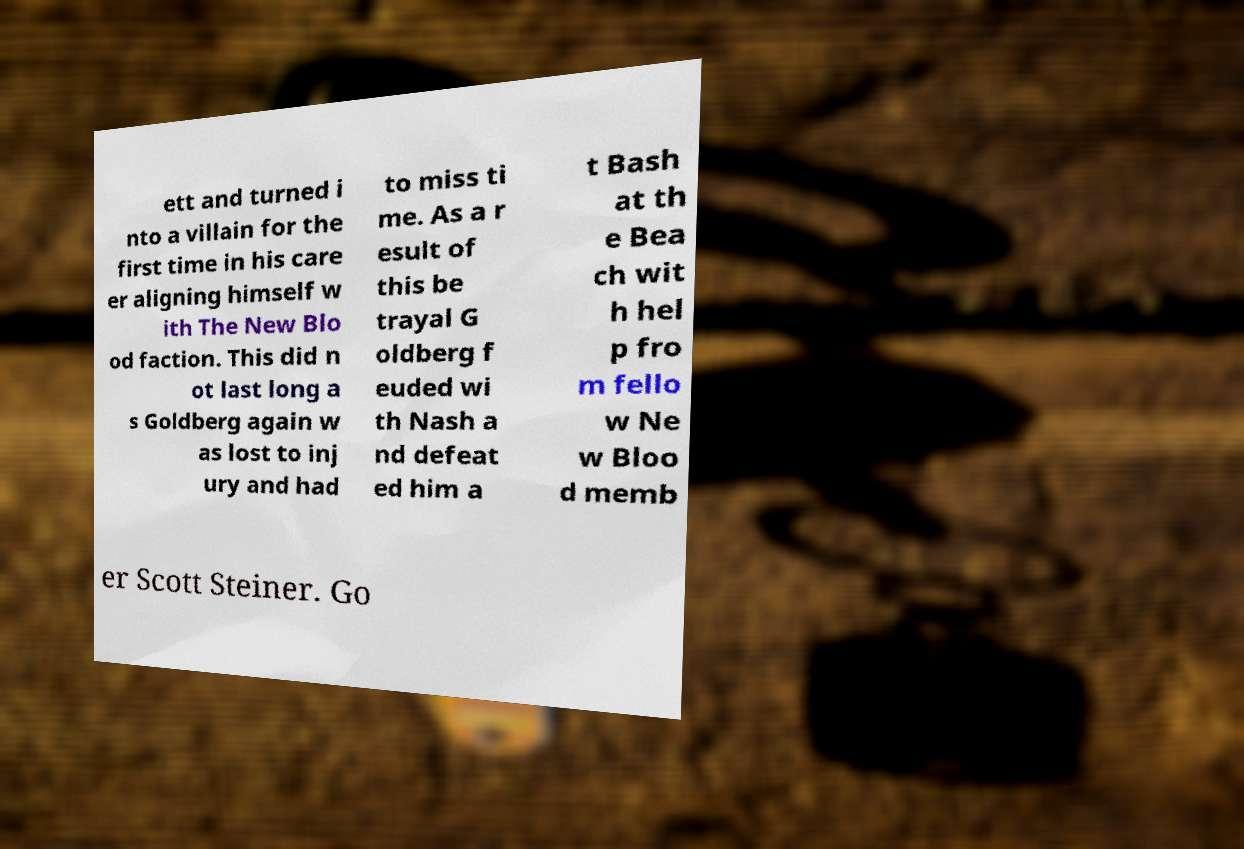Could you extract and type out the text from this image? ett and turned i nto a villain for the first time in his care er aligning himself w ith The New Blo od faction. This did n ot last long a s Goldberg again w as lost to inj ury and had to miss ti me. As a r esult of this be trayal G oldberg f euded wi th Nash a nd defeat ed him a t Bash at th e Bea ch wit h hel p fro m fello w Ne w Bloo d memb er Scott Steiner. Go 